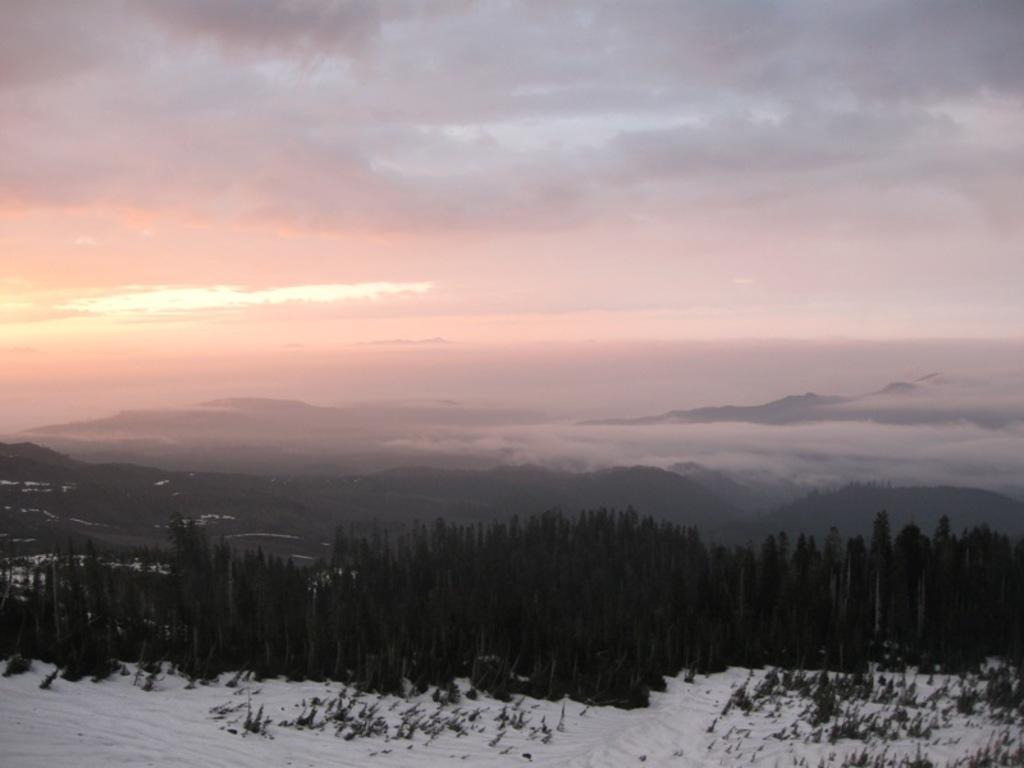Can you describe this image briefly? At the bottom we can see snow on the ground and trees. In the background there are mountains, fog and clouds in the sky. 